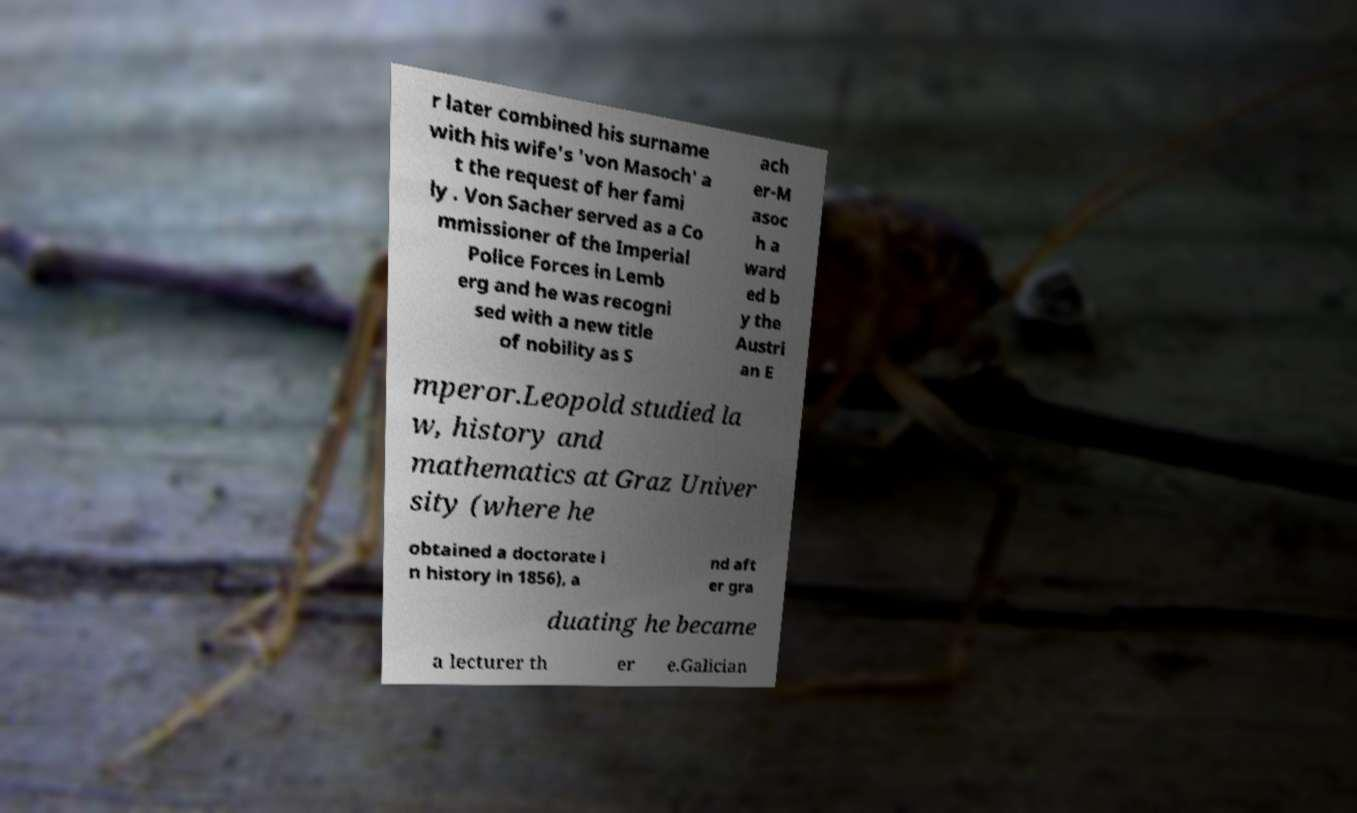Could you assist in decoding the text presented in this image and type it out clearly? r later combined his surname with his wife's 'von Masoch' a t the request of her fami ly . Von Sacher served as a Co mmissioner of the Imperial Police Forces in Lemb erg and he was recogni sed with a new title of nobility as S ach er-M asoc h a ward ed b y the Austri an E mperor.Leopold studied la w, history and mathematics at Graz Univer sity (where he obtained a doctorate i n history in 1856), a nd aft er gra duating he became a lecturer th er e.Galician 